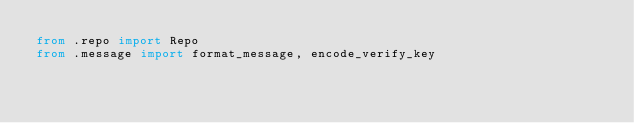Convert code to text. <code><loc_0><loc_0><loc_500><loc_500><_Python_>from .repo import Repo
from .message import format_message, encode_verify_key
</code> 